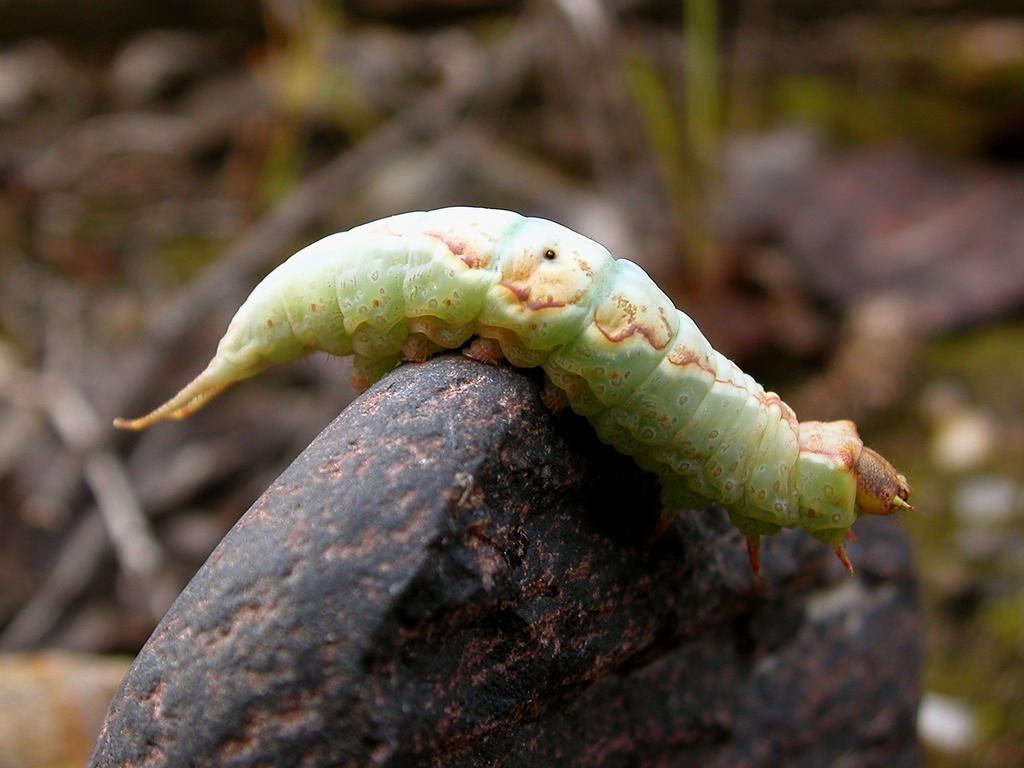What is the main subject of the picture? The main subject of the picture is a caterpillar. Where is the caterpillar located in the image? The caterpillar is on a stone. Can you describe the background of the image? The background of the image is blurred. What type of business is being conducted by the caterpillar in the image? There is no indication of any business activity in the image; it simply shows a caterpillar on a stone. Can you tell me how many noses the caterpillar has in the image? The caterpillar does not have a nose, as it is an insect and does not possess the same facial features as humans or other mammals. 